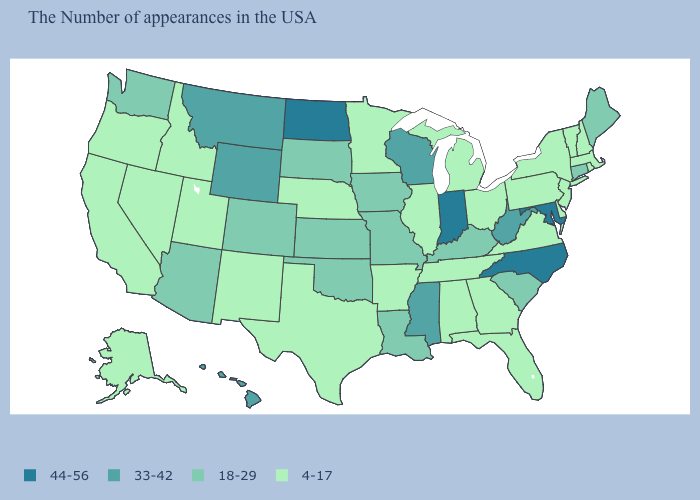Which states have the highest value in the USA?
Write a very short answer. Maryland, North Carolina, Indiana, North Dakota. Name the states that have a value in the range 18-29?
Be succinct. Maine, Connecticut, South Carolina, Kentucky, Louisiana, Missouri, Iowa, Kansas, Oklahoma, South Dakota, Colorado, Arizona, Washington. What is the value of Massachusetts?
Write a very short answer. 4-17. What is the value of Ohio?
Concise answer only. 4-17. Does Montana have a lower value than North Carolina?
Give a very brief answer. Yes. Name the states that have a value in the range 44-56?
Write a very short answer. Maryland, North Carolina, Indiana, North Dakota. Among the states that border Michigan , which have the highest value?
Give a very brief answer. Indiana. Name the states that have a value in the range 18-29?
Quick response, please. Maine, Connecticut, South Carolina, Kentucky, Louisiana, Missouri, Iowa, Kansas, Oklahoma, South Dakota, Colorado, Arizona, Washington. What is the value of Pennsylvania?
Keep it brief. 4-17. Which states have the lowest value in the USA?
Write a very short answer. Massachusetts, Rhode Island, New Hampshire, Vermont, New York, New Jersey, Delaware, Pennsylvania, Virginia, Ohio, Florida, Georgia, Michigan, Alabama, Tennessee, Illinois, Arkansas, Minnesota, Nebraska, Texas, New Mexico, Utah, Idaho, Nevada, California, Oregon, Alaska. Which states have the lowest value in the South?
Answer briefly. Delaware, Virginia, Florida, Georgia, Alabama, Tennessee, Arkansas, Texas. Among the states that border Washington , which have the highest value?
Answer briefly. Idaho, Oregon. What is the highest value in states that border Tennessee?
Give a very brief answer. 44-56. Which states have the lowest value in the USA?
Be succinct. Massachusetts, Rhode Island, New Hampshire, Vermont, New York, New Jersey, Delaware, Pennsylvania, Virginia, Ohio, Florida, Georgia, Michigan, Alabama, Tennessee, Illinois, Arkansas, Minnesota, Nebraska, Texas, New Mexico, Utah, Idaho, Nevada, California, Oregon, Alaska. What is the highest value in states that border Oklahoma?
Be succinct. 18-29. 